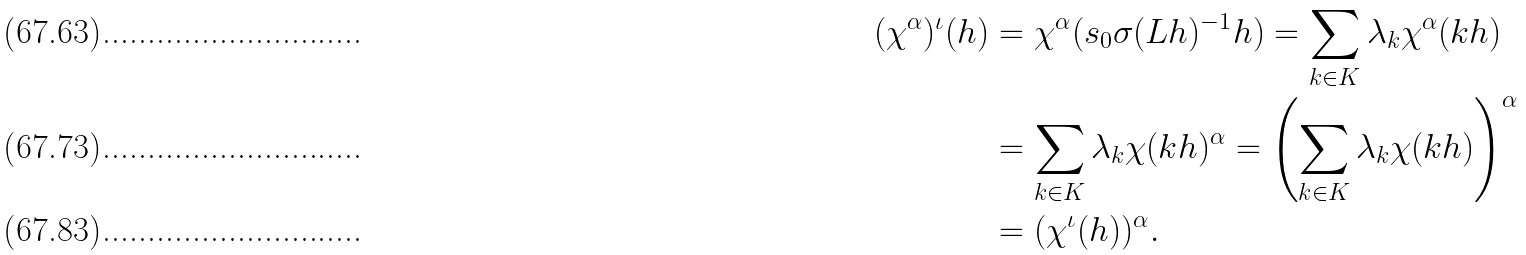<formula> <loc_0><loc_0><loc_500><loc_500>( \chi ^ { \alpha } ) ^ { \iota } ( h ) & = \chi ^ { \alpha } ( s _ { 0 } \sigma ( L h ) ^ { - 1 } h ) = \sum _ { k \in K } \lambda _ { k } \chi ^ { \alpha } ( k h ) \\ & = \sum _ { k \in K } \lambda _ { k } \chi ( k h ) ^ { \alpha } = \left ( \sum _ { k \in K } \lambda _ { k } \chi ( k h ) \right ) ^ { \alpha } \\ & = ( \chi ^ { \iota } ( h ) ) ^ { \alpha } .</formula> 